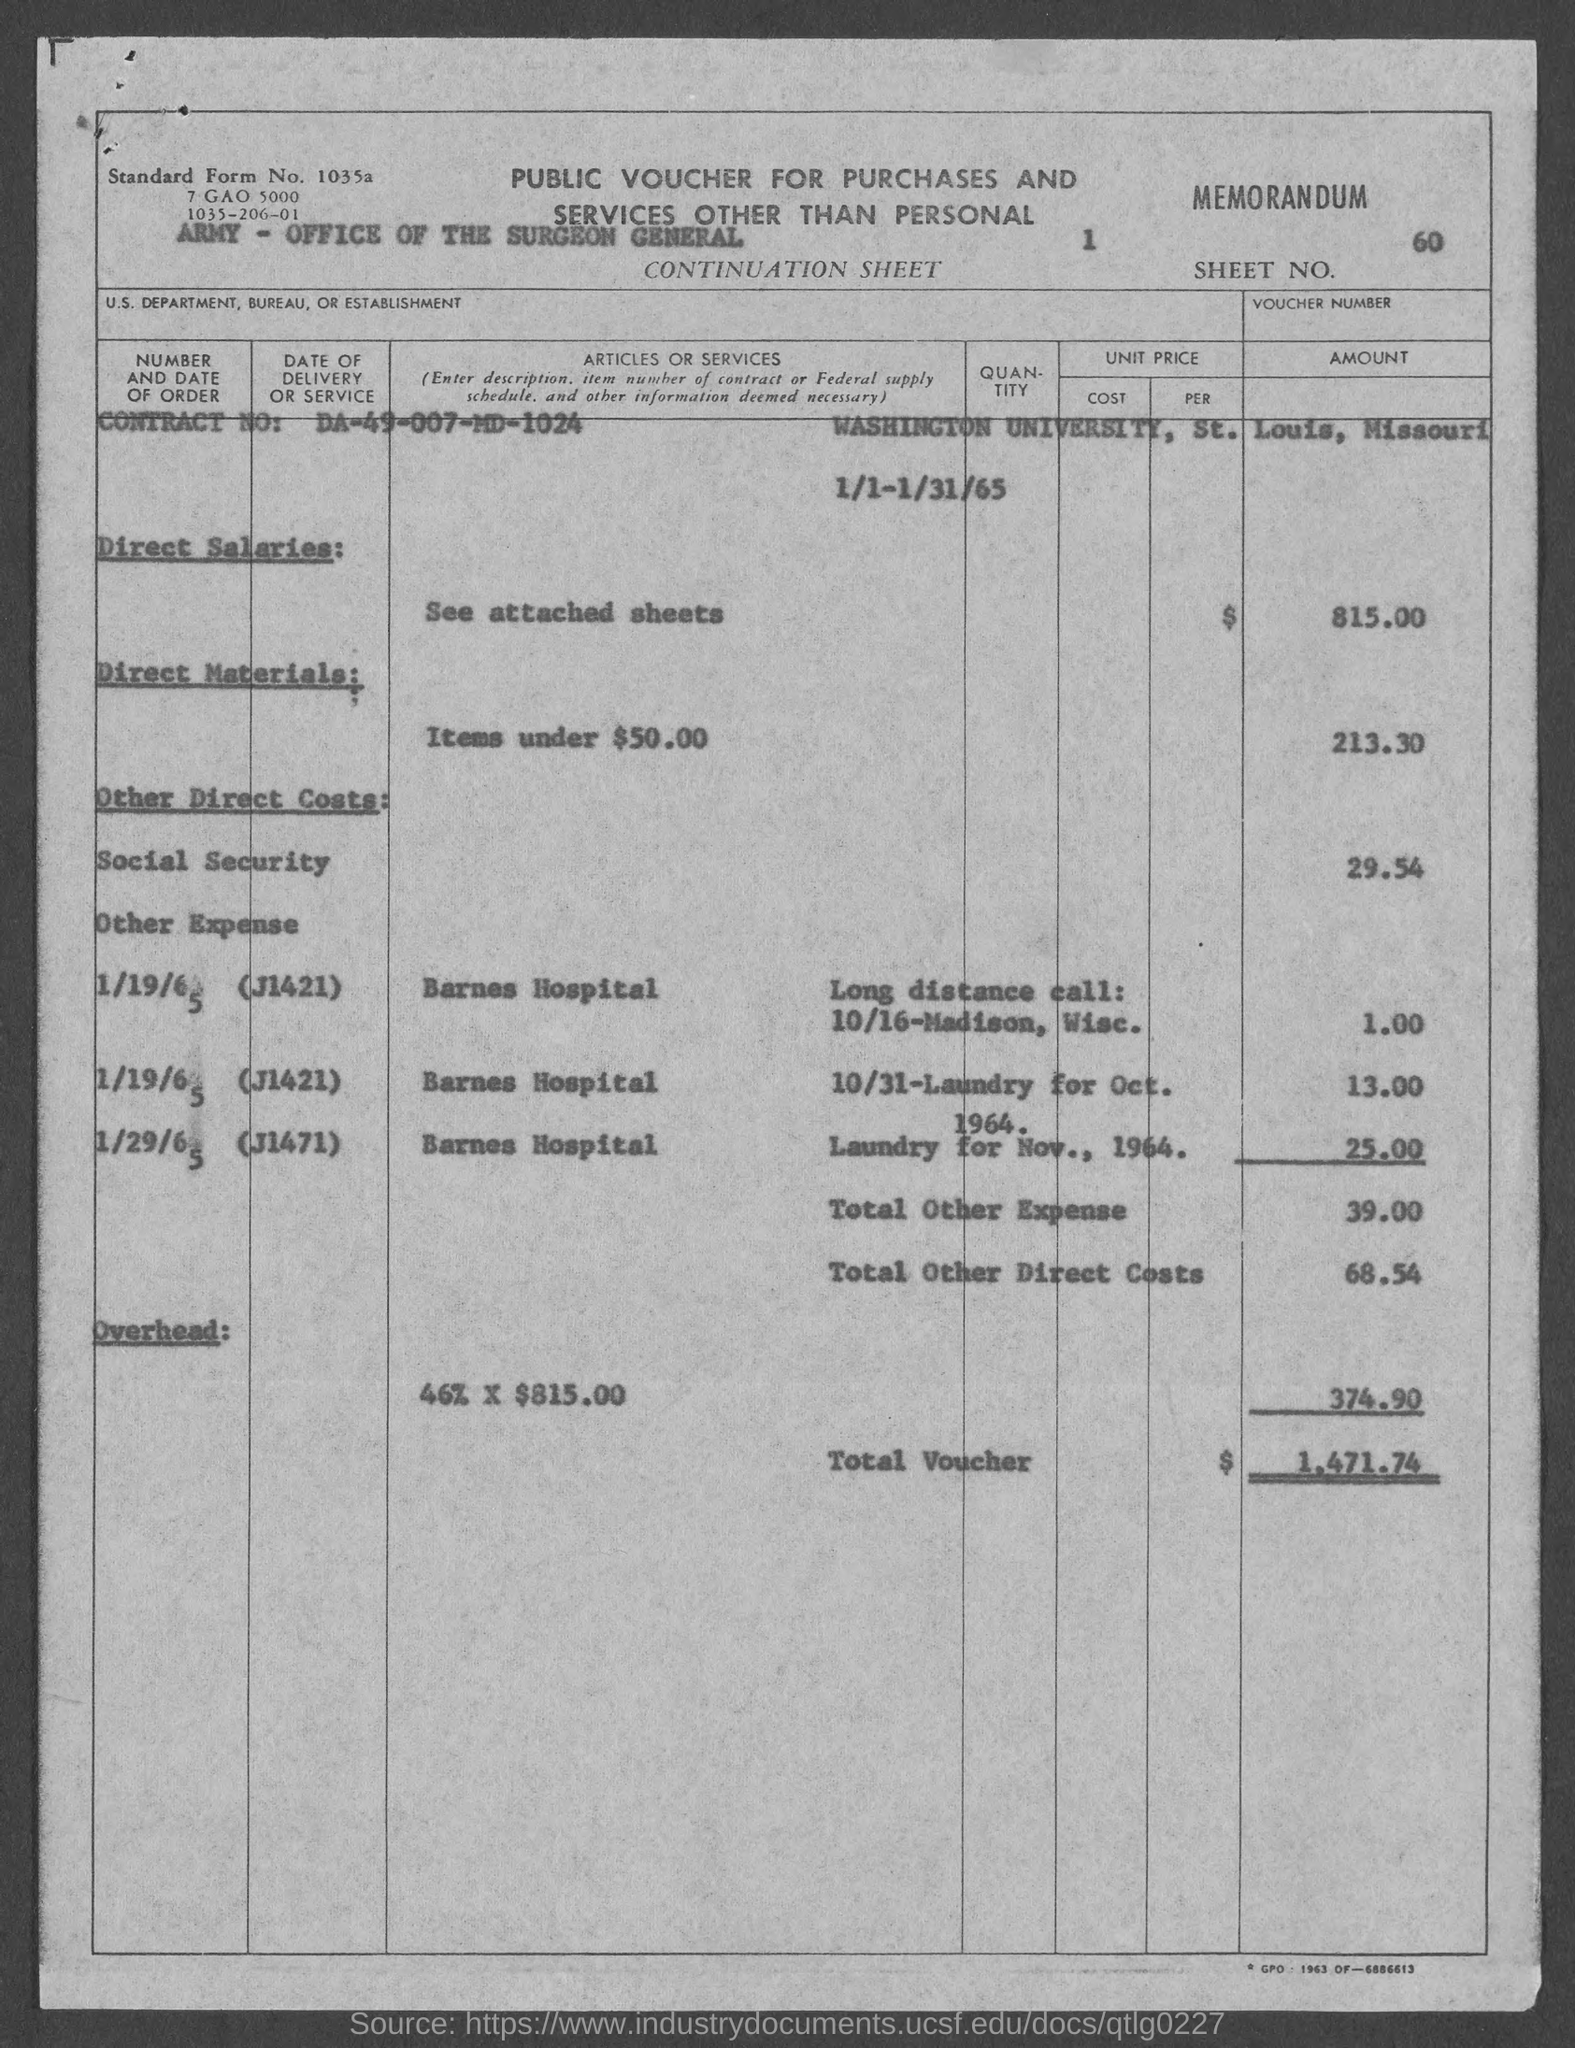What is the sheet no.?
Ensure brevity in your answer.  60. What is the standard form no.?
Keep it short and to the point. 1035a. What is the contract number ?
Provide a succinct answer. DA-49-007-MD-1024. What is the total voucher amount ?
Offer a very short reply. $1,471.74. What is the total other direct costs?
Your response must be concise. $68.54. What is the total other expense amount ?
Offer a very short reply. $39.00. 